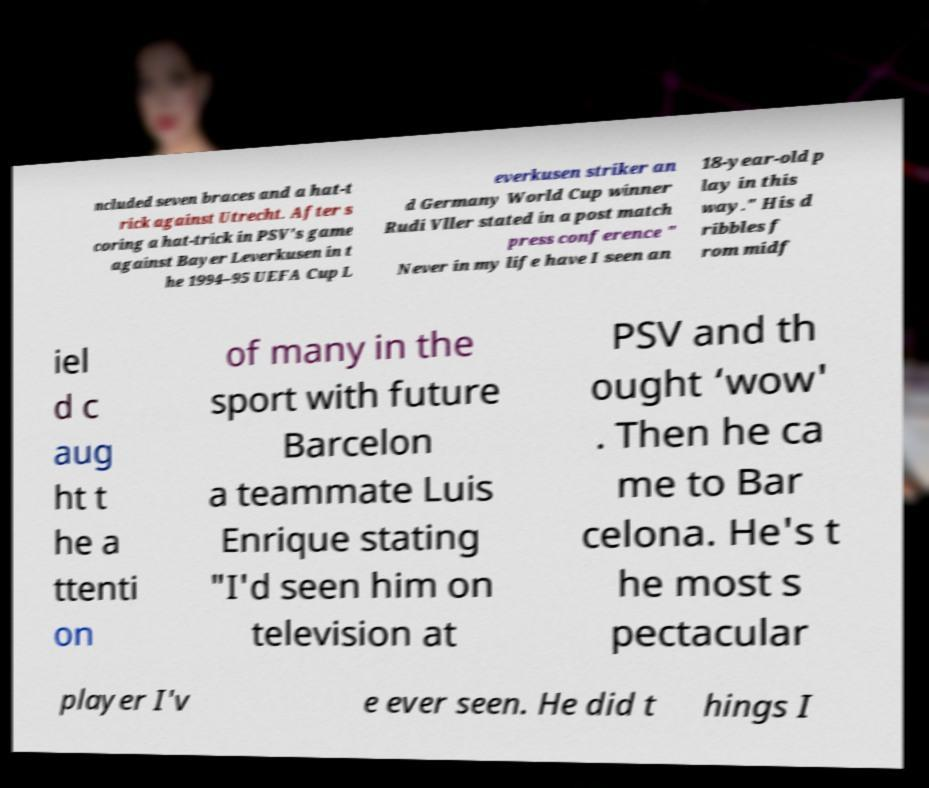Please read and relay the text visible in this image. What does it say? ncluded seven braces and a hat-t rick against Utrecht. After s coring a hat-trick in PSV's game against Bayer Leverkusen in t he 1994–95 UEFA Cup L everkusen striker an d Germany World Cup winner Rudi Vller stated in a post match press conference " Never in my life have I seen an 18-year-old p lay in this way." His d ribbles f rom midf iel d c aug ht t he a ttenti on of many in the sport with future Barcelon a teammate Luis Enrique stating "I'd seen him on television at PSV and th ought ‘wow' . Then he ca me to Bar celona. He's t he most s pectacular player I'v e ever seen. He did t hings I 